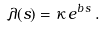<formula> <loc_0><loc_0><loc_500><loc_500>\lambda ( s ) = \kappa \, e ^ { b \, s } \, .</formula> 